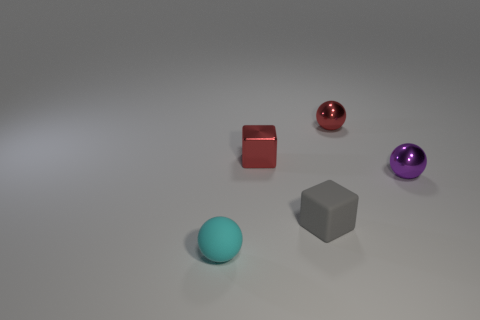Subtract 1 balls. How many balls are left? 2 Add 2 cyan matte cylinders. How many objects exist? 7 Subtract all spheres. How many objects are left? 2 Add 1 tiny cyan objects. How many tiny cyan objects are left? 2 Add 2 tiny spheres. How many tiny spheres exist? 5 Subtract 0 brown cubes. How many objects are left? 5 Subtract all large gray objects. Subtract all tiny rubber blocks. How many objects are left? 4 